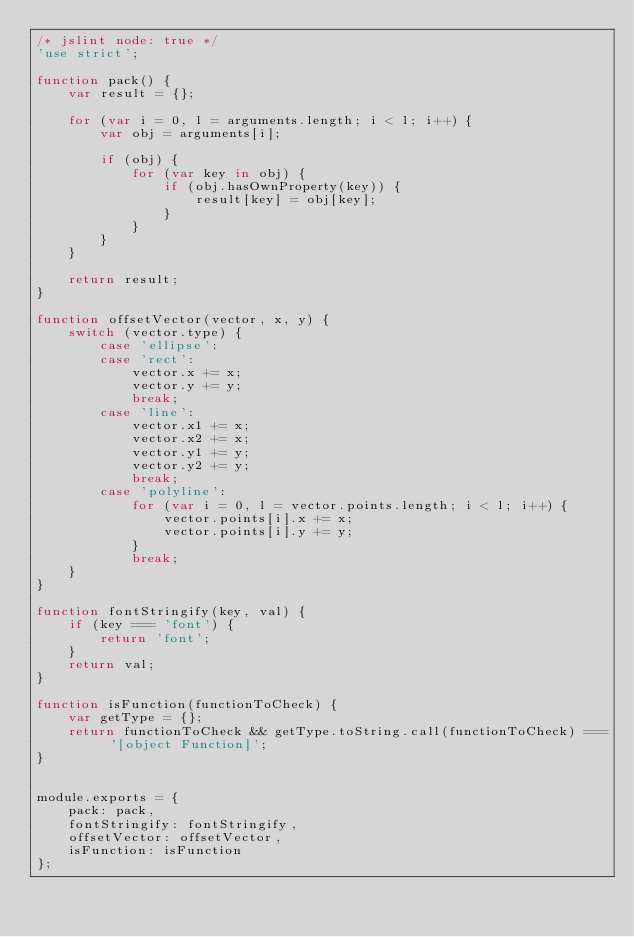Convert code to text. <code><loc_0><loc_0><loc_500><loc_500><_JavaScript_>/* jslint node: true */
'use strict';

function pack() {
	var result = {};

	for (var i = 0, l = arguments.length; i < l; i++) {
		var obj = arguments[i];

		if (obj) {
			for (var key in obj) {
				if (obj.hasOwnProperty(key)) {
					result[key] = obj[key];
				}
			}
		}
	}

	return result;
}

function offsetVector(vector, x, y) {
	switch (vector.type) {
		case 'ellipse':
		case 'rect':
			vector.x += x;
			vector.y += y;
			break;
		case 'line':
			vector.x1 += x;
			vector.x2 += x;
			vector.y1 += y;
			vector.y2 += y;
			break;
		case 'polyline':
			for (var i = 0, l = vector.points.length; i < l; i++) {
				vector.points[i].x += x;
				vector.points[i].y += y;
			}
			break;
	}
}

function fontStringify(key, val) {
	if (key === 'font') {
		return 'font';
	}
	return val;
}

function isFunction(functionToCheck) {
	var getType = {};
	return functionToCheck && getType.toString.call(functionToCheck) === '[object Function]';
}


module.exports = {
	pack: pack,
	fontStringify: fontStringify,
	offsetVector: offsetVector,
	isFunction: isFunction
};
</code> 